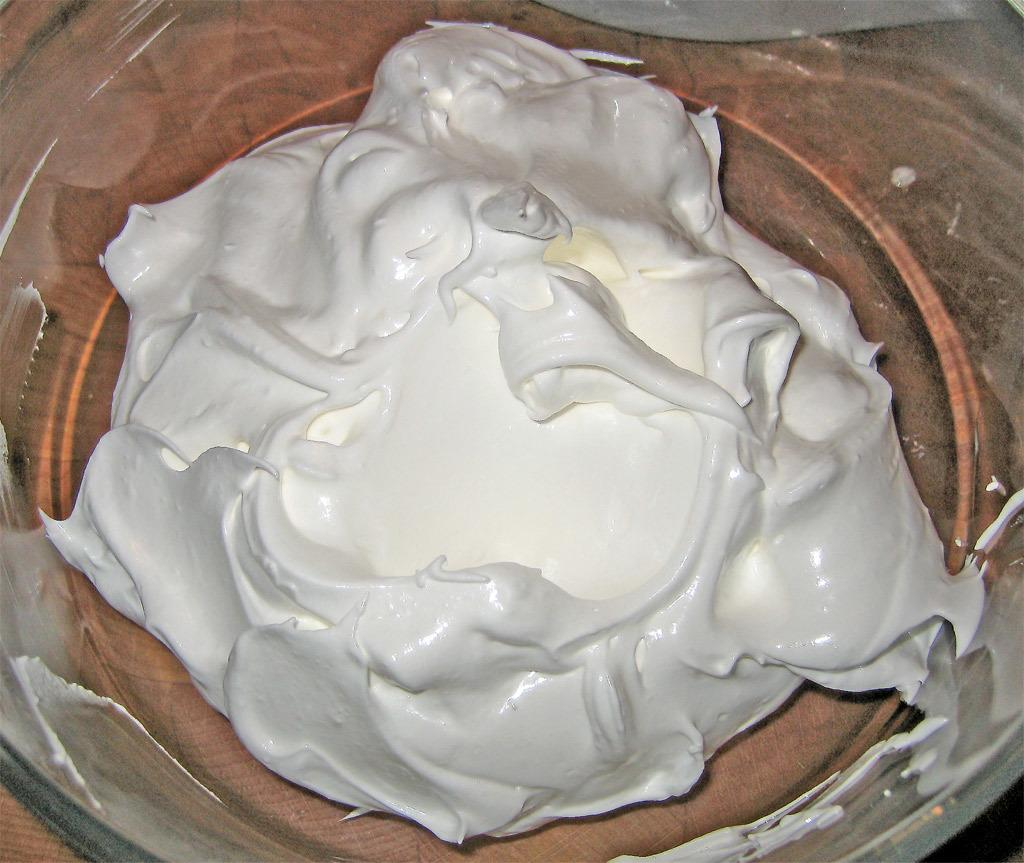What is the main subject of the image? The main subject of the image is a cream. How is the cream contained in the image? The cream is kept in a glass. How long does the existence of the collar last in the image? There is no collar present in the image, so it is not possible to determine the duration of its existence. 